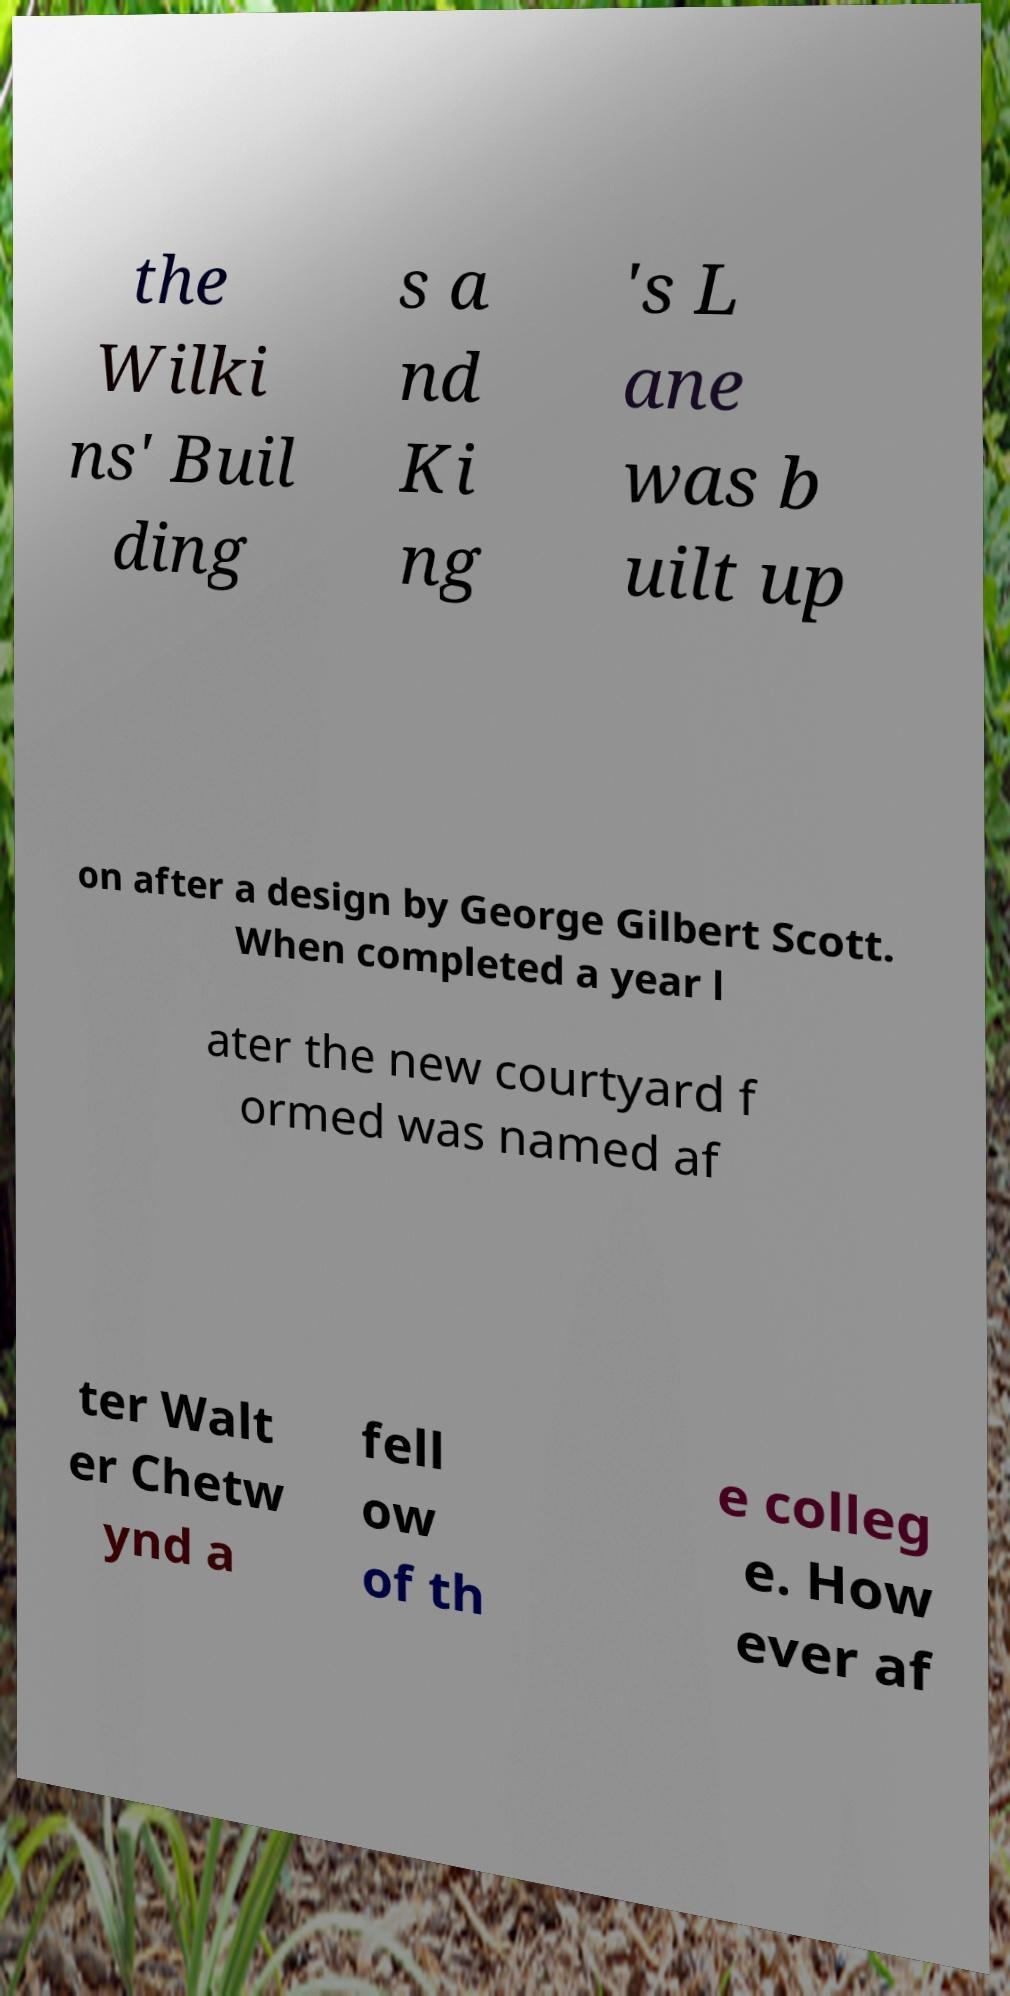I need the written content from this picture converted into text. Can you do that? the Wilki ns' Buil ding s a nd Ki ng 's L ane was b uilt up on after a design by George Gilbert Scott. When completed a year l ater the new courtyard f ormed was named af ter Walt er Chetw ynd a fell ow of th e colleg e. How ever af 